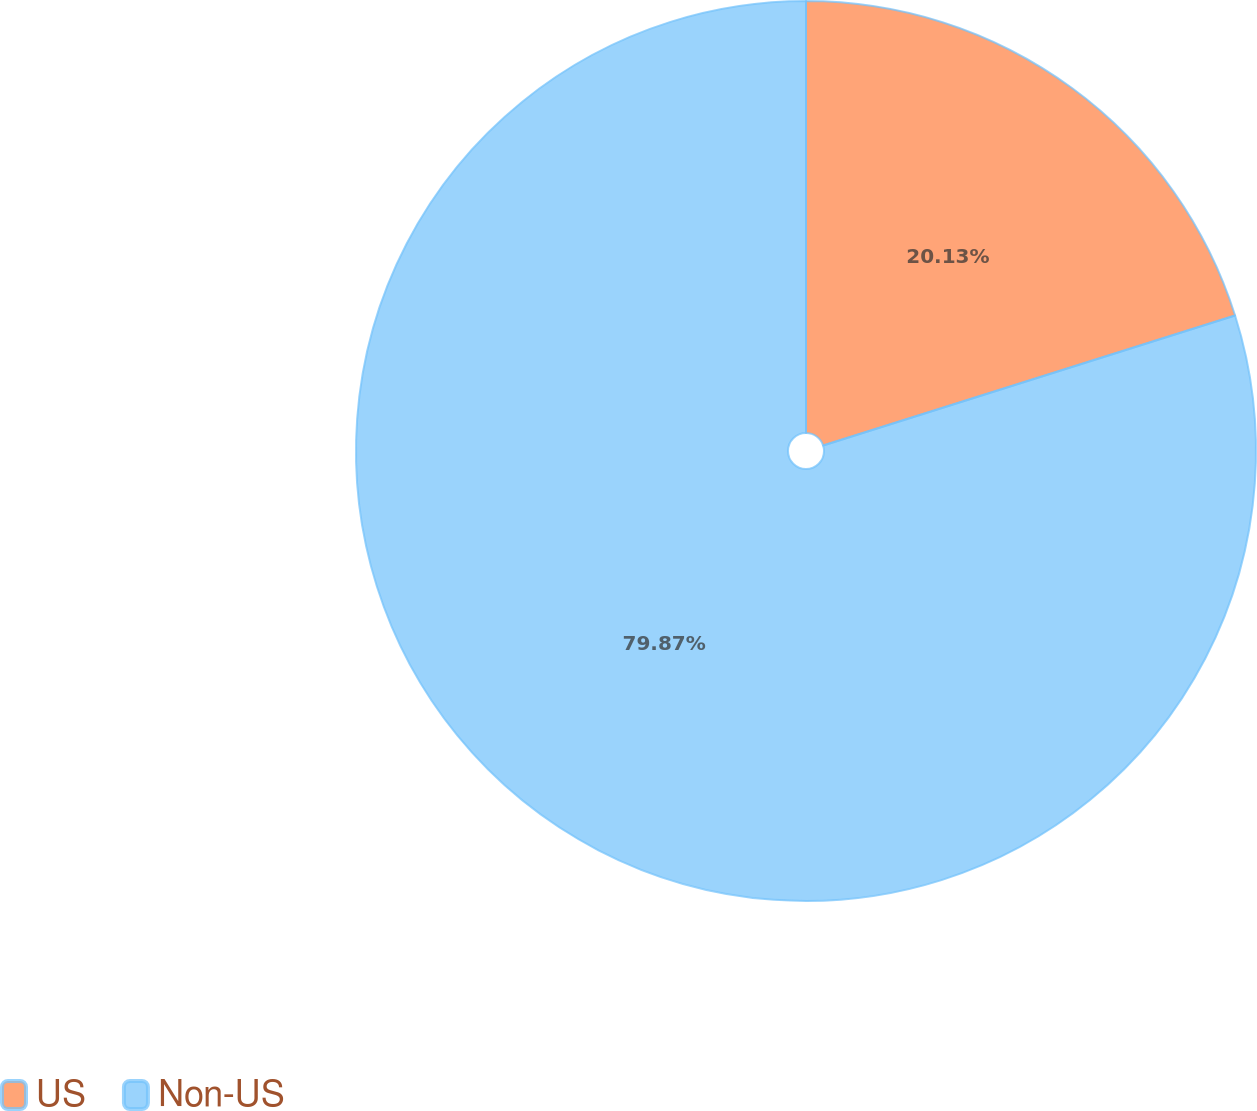Convert chart to OTSL. <chart><loc_0><loc_0><loc_500><loc_500><pie_chart><fcel>US<fcel>Non-US<nl><fcel>20.13%<fcel>79.87%<nl></chart> 